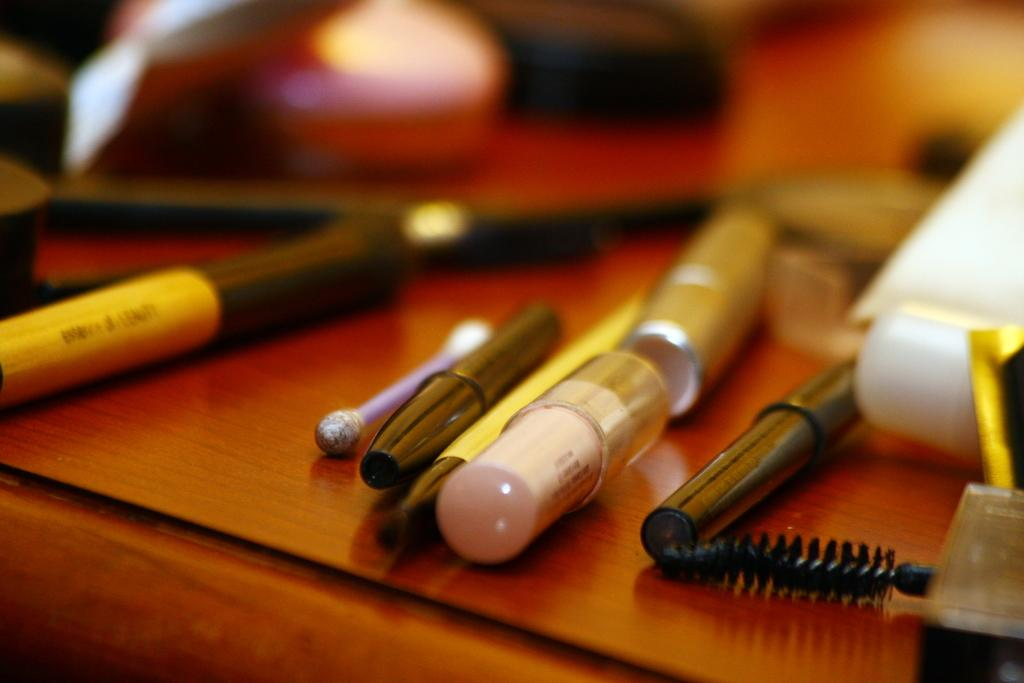What is the main subject of the image? The main subject of the image is objects on a table. Can you describe the background of the image? The background of the image is blurry. What type of shirt is hanging on the tree in the image? There is no tree or shirt present in the image. 